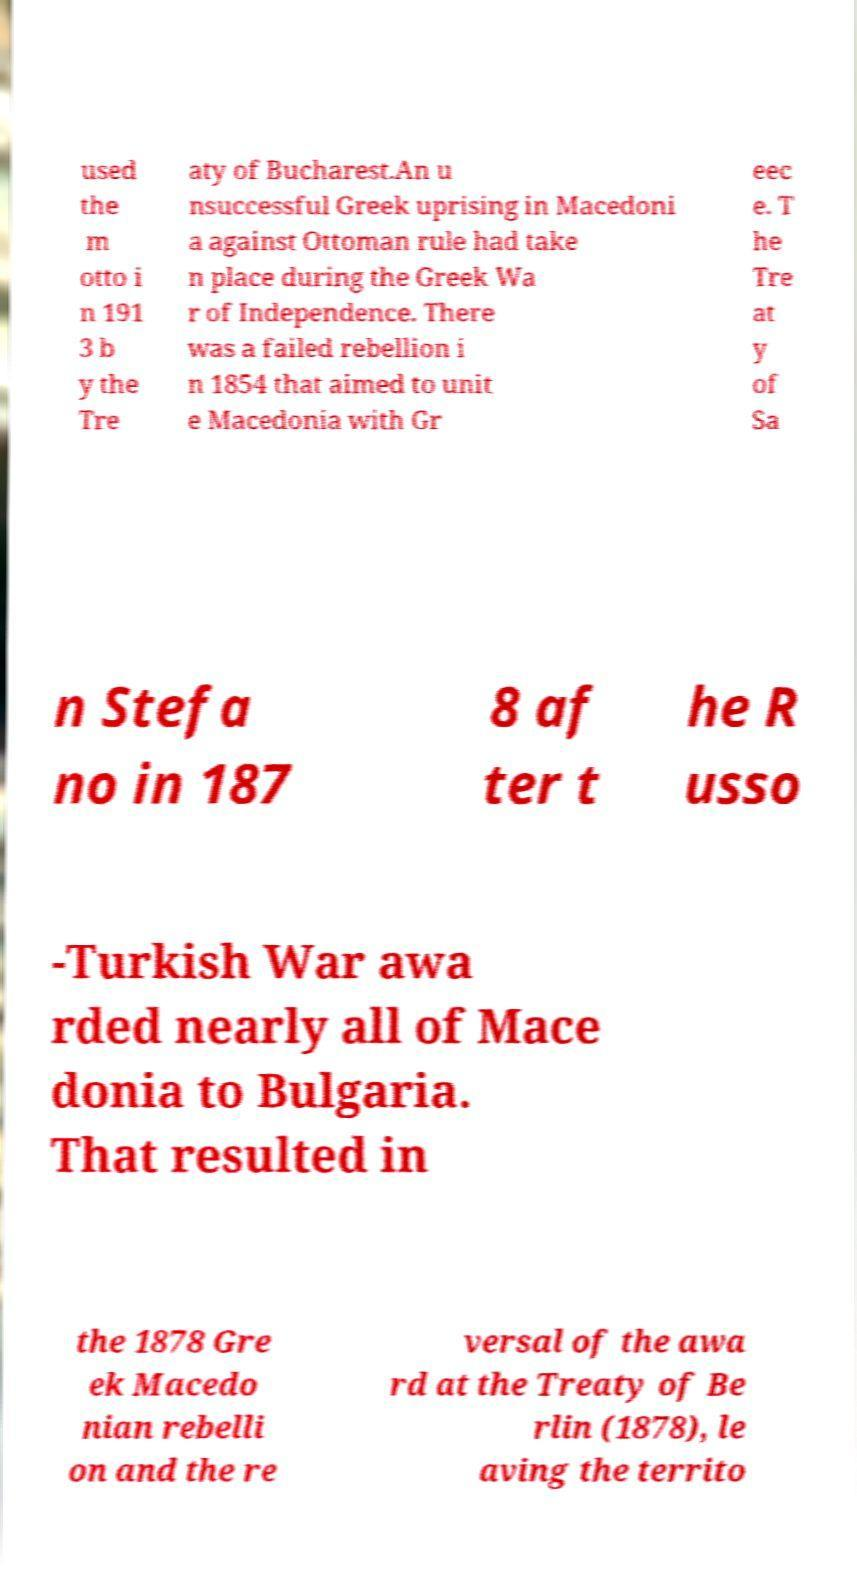Can you accurately transcribe the text from the provided image for me? used the m otto i n 191 3 b y the Tre aty of Bucharest.An u nsuccessful Greek uprising in Macedoni a against Ottoman rule had take n place during the Greek Wa r of Independence. There was a failed rebellion i n 1854 that aimed to unit e Macedonia with Gr eec e. T he Tre at y of Sa n Stefa no in 187 8 af ter t he R usso -Turkish War awa rded nearly all of Mace donia to Bulgaria. That resulted in the 1878 Gre ek Macedo nian rebelli on and the re versal of the awa rd at the Treaty of Be rlin (1878), le aving the territo 